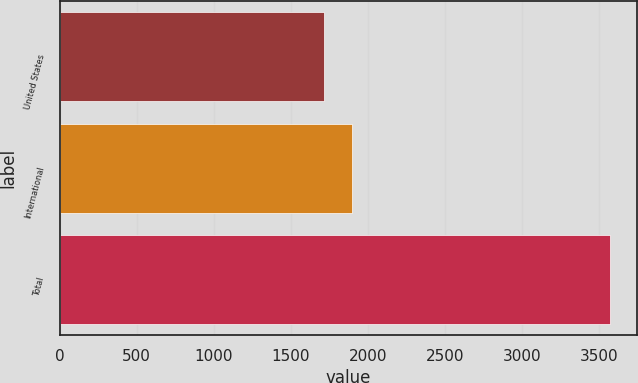<chart> <loc_0><loc_0><loc_500><loc_500><bar_chart><fcel>United States<fcel>International<fcel>Total<nl><fcel>1713.7<fcel>1898.93<fcel>3566<nl></chart> 